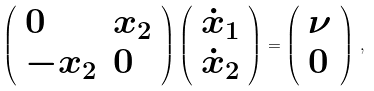<formula> <loc_0><loc_0><loc_500><loc_500>\left ( \begin{array} { l l } { 0 } & { { x _ { 2 } } } \\ { { - x _ { 2 } } } & { 0 } \end{array} \right ) \left ( \begin{array} { l } { { \dot { x } _ { 1 } } } \\ { { \dot { x } _ { 2 } } } \end{array} \right ) = \left ( \begin{array} { l } { \nu } \\ { 0 } \end{array} \right ) \, ,</formula> 